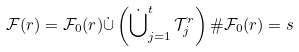Convert formula to latex. <formula><loc_0><loc_0><loc_500><loc_500>\mathcal { F } ( r ) = \mathcal { F } _ { 0 } ( r ) \dot { \cup } \left ( \dot { \bigcup } _ { j = 1 } ^ { t } \, \mathcal { T } _ { j } ^ { r } \right ) \# \mathcal { F } _ { 0 } ( r ) = s</formula> 